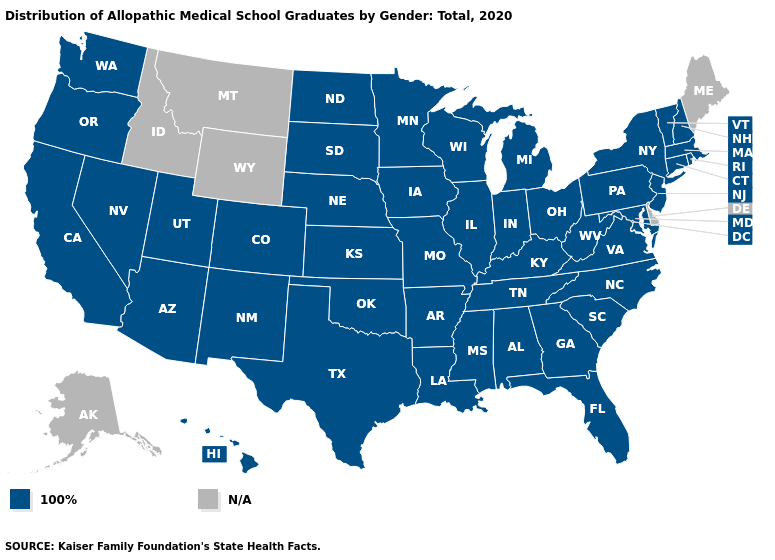Name the states that have a value in the range N/A?
Write a very short answer. Alaska, Delaware, Idaho, Maine, Montana, Wyoming. Which states have the lowest value in the South?
Be succinct. Alabama, Arkansas, Florida, Georgia, Kentucky, Louisiana, Maryland, Mississippi, North Carolina, Oklahoma, South Carolina, Tennessee, Texas, Virginia, West Virginia. Name the states that have a value in the range N/A?
Be succinct. Alaska, Delaware, Idaho, Maine, Montana, Wyoming. Name the states that have a value in the range 100%?
Give a very brief answer. Alabama, Arizona, Arkansas, California, Colorado, Connecticut, Florida, Georgia, Hawaii, Illinois, Indiana, Iowa, Kansas, Kentucky, Louisiana, Maryland, Massachusetts, Michigan, Minnesota, Mississippi, Missouri, Nebraska, Nevada, New Hampshire, New Jersey, New Mexico, New York, North Carolina, North Dakota, Ohio, Oklahoma, Oregon, Pennsylvania, Rhode Island, South Carolina, South Dakota, Tennessee, Texas, Utah, Vermont, Virginia, Washington, West Virginia, Wisconsin. Name the states that have a value in the range 100%?
Give a very brief answer. Alabama, Arizona, Arkansas, California, Colorado, Connecticut, Florida, Georgia, Hawaii, Illinois, Indiana, Iowa, Kansas, Kentucky, Louisiana, Maryland, Massachusetts, Michigan, Minnesota, Mississippi, Missouri, Nebraska, Nevada, New Hampshire, New Jersey, New Mexico, New York, North Carolina, North Dakota, Ohio, Oklahoma, Oregon, Pennsylvania, Rhode Island, South Carolina, South Dakota, Tennessee, Texas, Utah, Vermont, Virginia, Washington, West Virginia, Wisconsin. What is the value of Kansas?
Answer briefly. 100%. Name the states that have a value in the range N/A?
Keep it brief. Alaska, Delaware, Idaho, Maine, Montana, Wyoming. Name the states that have a value in the range 100%?
Concise answer only. Alabama, Arizona, Arkansas, California, Colorado, Connecticut, Florida, Georgia, Hawaii, Illinois, Indiana, Iowa, Kansas, Kentucky, Louisiana, Maryland, Massachusetts, Michigan, Minnesota, Mississippi, Missouri, Nebraska, Nevada, New Hampshire, New Jersey, New Mexico, New York, North Carolina, North Dakota, Ohio, Oklahoma, Oregon, Pennsylvania, Rhode Island, South Carolina, South Dakota, Tennessee, Texas, Utah, Vermont, Virginia, Washington, West Virginia, Wisconsin. What is the highest value in states that border Wyoming?
Answer briefly. 100%. Name the states that have a value in the range 100%?
Give a very brief answer. Alabama, Arizona, Arkansas, California, Colorado, Connecticut, Florida, Georgia, Hawaii, Illinois, Indiana, Iowa, Kansas, Kentucky, Louisiana, Maryland, Massachusetts, Michigan, Minnesota, Mississippi, Missouri, Nebraska, Nevada, New Hampshire, New Jersey, New Mexico, New York, North Carolina, North Dakota, Ohio, Oklahoma, Oregon, Pennsylvania, Rhode Island, South Carolina, South Dakota, Tennessee, Texas, Utah, Vermont, Virginia, Washington, West Virginia, Wisconsin. Name the states that have a value in the range N/A?
Give a very brief answer. Alaska, Delaware, Idaho, Maine, Montana, Wyoming. 